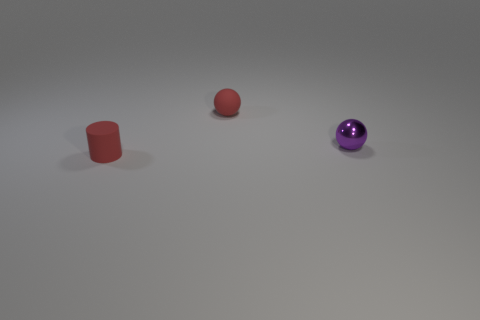How is the lighting arranged in this scene? The lighting in the image seems to be arranged in a way that creates soft shadows to the right of the objects, suggesting a diffused light source situated to the left, possibly out of frame. The light does not create harsh edges, hinting at a studio lighting set-up with possible overhead and fill lights to achieve an even distribution of light across the scene. 